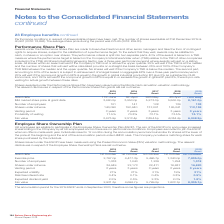According to Spirax Sarco Engineering Plc's financial document, What is the aim of the ESOP? to encourage increased shareholding in the Company by all UK employees and so there are no performance conditions. The document states: "are Ownership Plan (ESOP). The aim of the ESOP is to encourage increased shareholding in the Company by all UK employees and so there are no performan..." Also, When does the accumulation period for the 2019 ESOP end? According to the financial document, September 2020. The relevant text states: "The accumulation period for the 2019 ESOP ends in September 2020, therefore some figures are projections...." Also, For which years of share issuance are the relevant disclosures in respect of the Employee Share Ownership Plans analysed? The document contains multiple relevant values: 2015, 2016, 2017, 2018, 2019. From the document: "ares exercisable at 31st December 2019 is 40,901 (2018: 78,498). The average share price during the period was £75.65 (2018: £59.30). 2015 Grant 2016 ..." Additionally, In which grant year was the risk free interest rate the highest? According to the financial document, 2018. The relevant text states: "ares exercisable at 31st December 2019 is 40,901 (2018: 78,498). The average share price during the period was £75.65 (2018: £59.30)...." Also, can you calculate: What was the change in the number of employees in 2019 from 2018? Based on the calculation: 1,318-1,294, the result is 24. This is based on the information: "Number of employees 1,038 1,040 1,229 1,294 1,318 Number of employees 1,038 1,040 1,229 1,294 1,318..." The key data points involved are: 1,294, 1,318. Also, can you calculate: What was the percentage change in the number of employees in 2019 from 2018? To answer this question, I need to perform calculations using the financial data. The calculation is: (1,318-1,294)/1,294, which equals 1.85 (percentage). This is based on the information: "Number of employees 1,038 1,040 1,229 1,294 1,318 Number of employees 1,038 1,040 1,229 1,294 1,318..." The key data points involved are: 1,294, 1,318. 